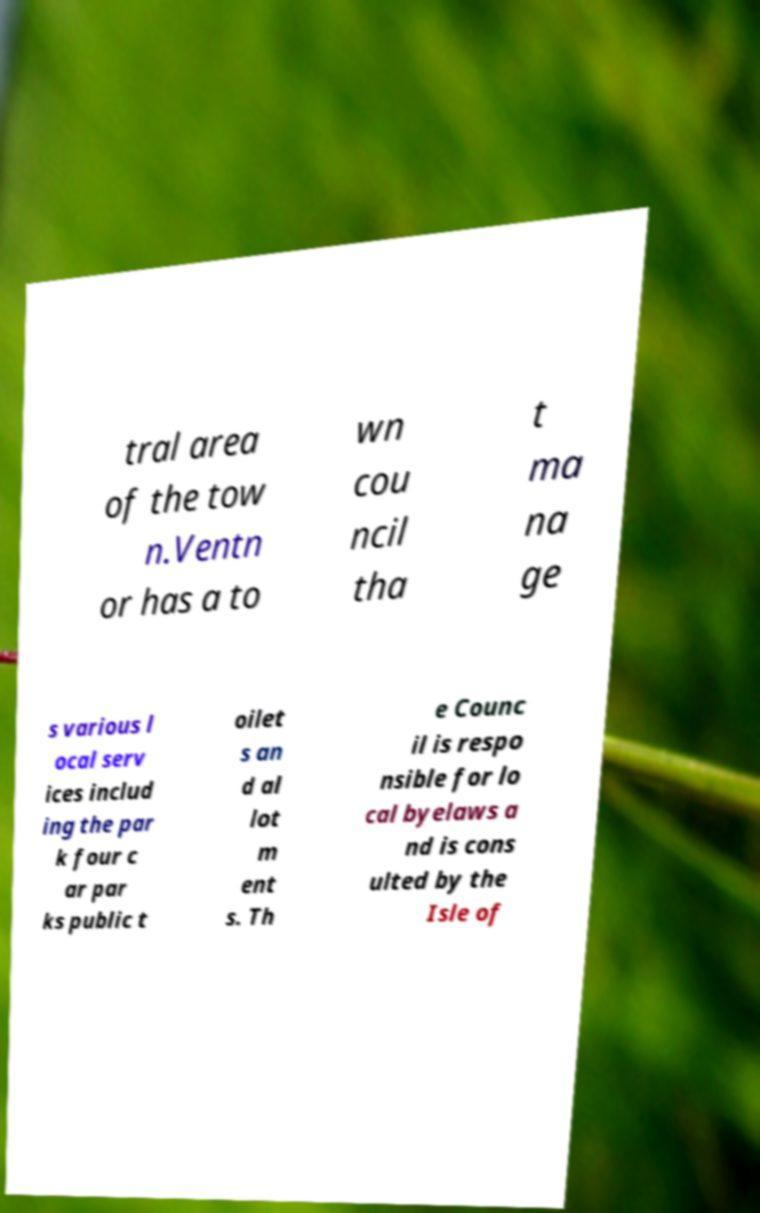Could you assist in decoding the text presented in this image and type it out clearly? tral area of the tow n.Ventn or has a to wn cou ncil tha t ma na ge s various l ocal serv ices includ ing the par k four c ar par ks public t oilet s an d al lot m ent s. Th e Counc il is respo nsible for lo cal byelaws a nd is cons ulted by the Isle of 